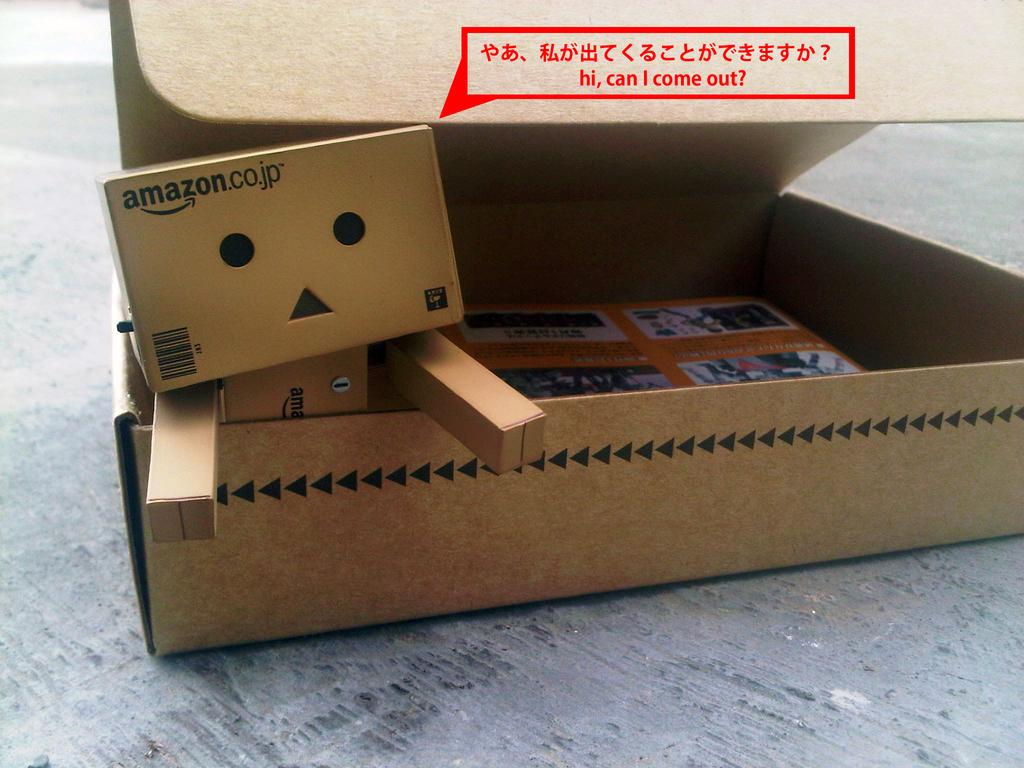<image>
Relay a brief, clear account of the picture shown. Cardboard boxes from Amazon are arranged to look like a person. 